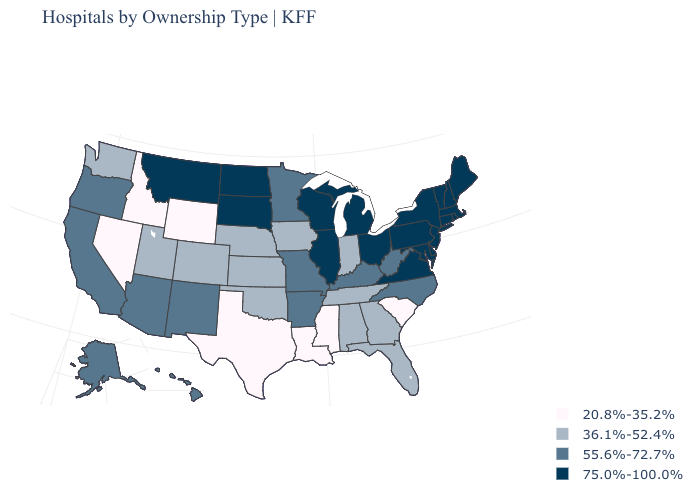Name the states that have a value in the range 36.1%-52.4%?
Quick response, please. Alabama, Colorado, Florida, Georgia, Indiana, Iowa, Kansas, Nebraska, Oklahoma, Tennessee, Utah, Washington. Does the map have missing data?
Be succinct. No. Does Minnesota have the lowest value in the MidWest?
Concise answer only. No. Name the states that have a value in the range 20.8%-35.2%?
Write a very short answer. Idaho, Louisiana, Mississippi, Nevada, South Carolina, Texas, Wyoming. Which states hav the highest value in the Northeast?
Keep it brief. Connecticut, Maine, Massachusetts, New Hampshire, New Jersey, New York, Pennsylvania, Rhode Island, Vermont. Does South Dakota have the highest value in the MidWest?
Short answer required. Yes. Which states have the lowest value in the MidWest?
Keep it brief. Indiana, Iowa, Kansas, Nebraska. Name the states that have a value in the range 36.1%-52.4%?
Quick response, please. Alabama, Colorado, Florida, Georgia, Indiana, Iowa, Kansas, Nebraska, Oklahoma, Tennessee, Utah, Washington. What is the lowest value in states that border Montana?
Be succinct. 20.8%-35.2%. What is the value of Michigan?
Concise answer only. 75.0%-100.0%. Name the states that have a value in the range 36.1%-52.4%?
Quick response, please. Alabama, Colorado, Florida, Georgia, Indiana, Iowa, Kansas, Nebraska, Oklahoma, Tennessee, Utah, Washington. Does the map have missing data?
Be succinct. No. Among the states that border Michigan , which have the highest value?
Write a very short answer. Ohio, Wisconsin. Does Arizona have the same value as Montana?
Short answer required. No. What is the lowest value in states that border Maine?
Concise answer only. 75.0%-100.0%. 